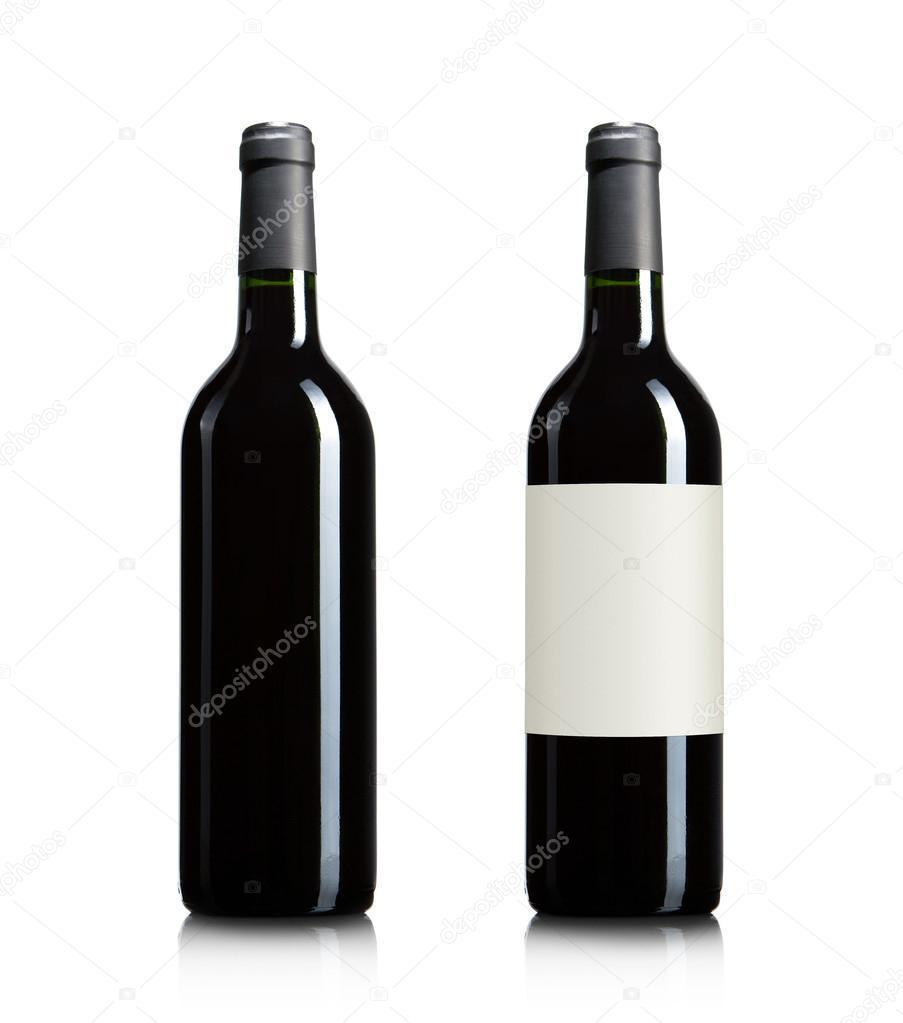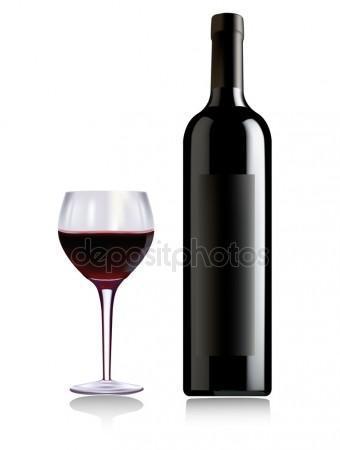The first image is the image on the left, the second image is the image on the right. Considering the images on both sides, is "One of the images has a bottle in a holder paired with a bottle with a label, but all wine bottles are otherwise without labels." valid? Answer yes or no. No. 